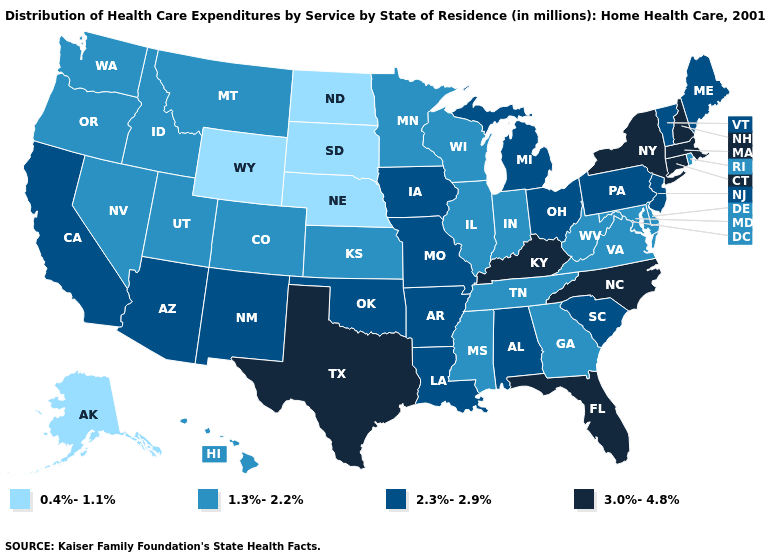Name the states that have a value in the range 1.3%-2.2%?
Write a very short answer. Colorado, Delaware, Georgia, Hawaii, Idaho, Illinois, Indiana, Kansas, Maryland, Minnesota, Mississippi, Montana, Nevada, Oregon, Rhode Island, Tennessee, Utah, Virginia, Washington, West Virginia, Wisconsin. What is the lowest value in the USA?
Concise answer only. 0.4%-1.1%. What is the value of Connecticut?
Write a very short answer. 3.0%-4.8%. What is the highest value in states that border Minnesota?
Concise answer only. 2.3%-2.9%. Name the states that have a value in the range 1.3%-2.2%?
Short answer required. Colorado, Delaware, Georgia, Hawaii, Idaho, Illinois, Indiana, Kansas, Maryland, Minnesota, Mississippi, Montana, Nevada, Oregon, Rhode Island, Tennessee, Utah, Virginia, Washington, West Virginia, Wisconsin. Name the states that have a value in the range 0.4%-1.1%?
Write a very short answer. Alaska, Nebraska, North Dakota, South Dakota, Wyoming. Among the states that border California , which have the highest value?
Answer briefly. Arizona. Does Virginia have a lower value than Minnesota?
Write a very short answer. No. Among the states that border Montana , does Idaho have the highest value?
Concise answer only. Yes. Among the states that border Alabama , which have the highest value?
Be succinct. Florida. Among the states that border Nevada , which have the lowest value?
Keep it brief. Idaho, Oregon, Utah. What is the highest value in states that border Utah?
Quick response, please. 2.3%-2.9%. Does the map have missing data?
Write a very short answer. No. What is the value of Kansas?
Quick response, please. 1.3%-2.2%. What is the value of Illinois?
Give a very brief answer. 1.3%-2.2%. 